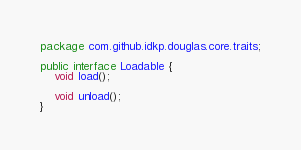<code> <loc_0><loc_0><loc_500><loc_500><_Java_>package com.github.idkp.douglas.core.traits;

public interface Loadable {
    void load();

    void unload();
}
</code> 